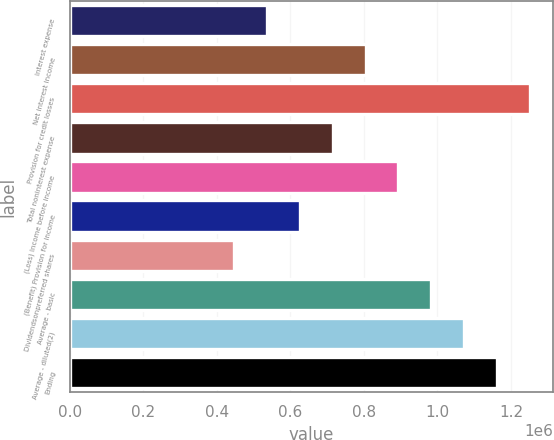Convert chart. <chart><loc_0><loc_0><loc_500><loc_500><bar_chart><fcel>Interest expense<fcel>Net interest income<fcel>Provision for credit losses<fcel>Total noninterest expense<fcel>(Loss) Income before income<fcel>(Benefit) Provision for income<fcel>Dividendsonpreferred shares<fcel>Average - basic<fcel>Average - diluted(2)<fcel>Ending<nl><fcel>536395<fcel>804592<fcel>1.25159e+06<fcel>715193<fcel>893991<fcel>625794<fcel>446996<fcel>983390<fcel>1.07279e+06<fcel>1.16219e+06<nl></chart> 